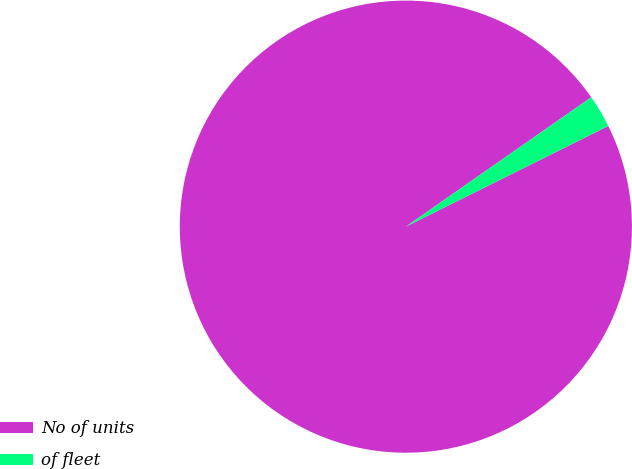Convert chart. <chart><loc_0><loc_0><loc_500><loc_500><pie_chart><fcel>No of units<fcel>of fleet<nl><fcel>97.65%<fcel>2.35%<nl></chart> 